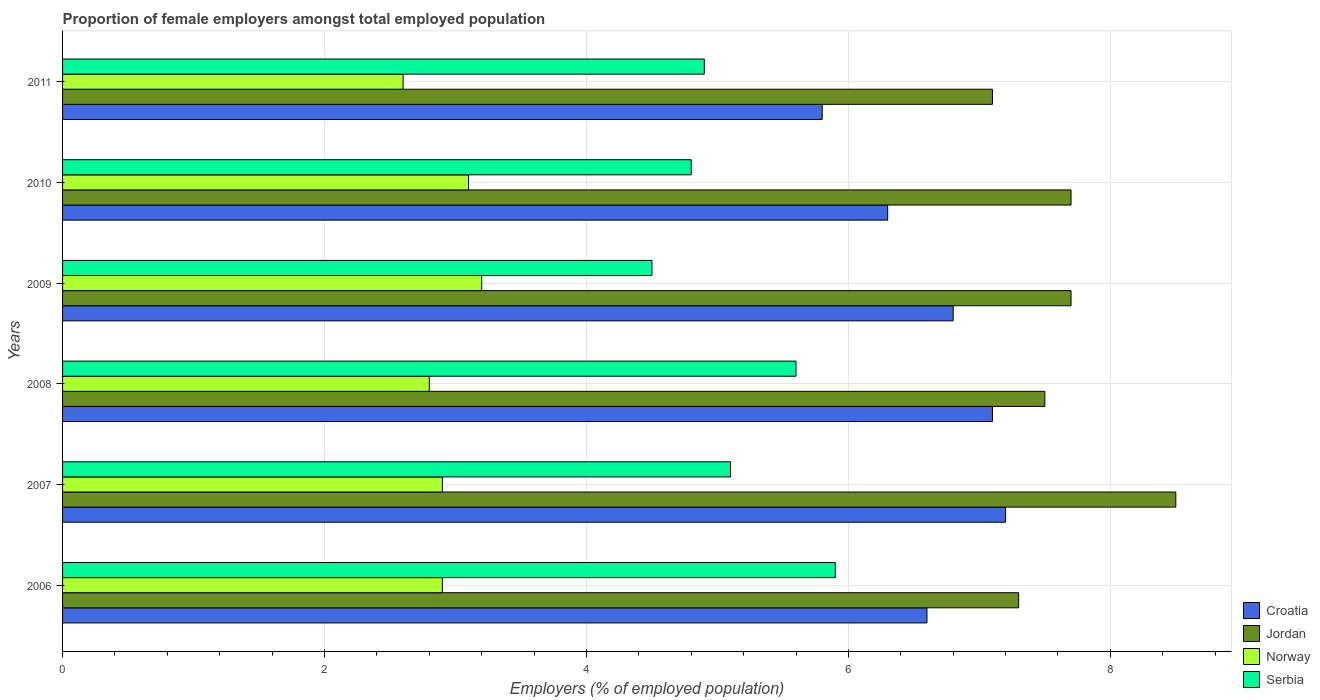How many different coloured bars are there?
Your answer should be compact. 4. Are the number of bars per tick equal to the number of legend labels?
Keep it short and to the point. Yes. How many bars are there on the 5th tick from the top?
Provide a succinct answer. 4. How many bars are there on the 4th tick from the bottom?
Your answer should be very brief. 4. In how many cases, is the number of bars for a given year not equal to the number of legend labels?
Provide a short and direct response. 0. What is the proportion of female employers in Croatia in 2007?
Ensure brevity in your answer.  7.2. Across all years, what is the minimum proportion of female employers in Croatia?
Offer a very short reply. 5.8. In which year was the proportion of female employers in Croatia minimum?
Ensure brevity in your answer.  2011. What is the total proportion of female employers in Jordan in the graph?
Your answer should be compact. 45.8. What is the difference between the proportion of female employers in Serbia in 2007 and that in 2010?
Provide a short and direct response. 0.3. What is the average proportion of female employers in Serbia per year?
Give a very brief answer. 5.13. In the year 2006, what is the difference between the proportion of female employers in Croatia and proportion of female employers in Norway?
Your response must be concise. 3.7. In how many years, is the proportion of female employers in Jordan greater than 8.4 %?
Ensure brevity in your answer.  1. What is the ratio of the proportion of female employers in Serbia in 2007 to that in 2010?
Your response must be concise. 1.06. Is the difference between the proportion of female employers in Croatia in 2008 and 2011 greater than the difference between the proportion of female employers in Norway in 2008 and 2011?
Keep it short and to the point. Yes. What is the difference between the highest and the second highest proportion of female employers in Serbia?
Keep it short and to the point. 0.3. What is the difference between the highest and the lowest proportion of female employers in Jordan?
Offer a very short reply. 1.4. In how many years, is the proportion of female employers in Jordan greater than the average proportion of female employers in Jordan taken over all years?
Give a very brief answer. 3. Is the sum of the proportion of female employers in Jordan in 2006 and 2010 greater than the maximum proportion of female employers in Croatia across all years?
Give a very brief answer. Yes. Is it the case that in every year, the sum of the proportion of female employers in Croatia and proportion of female employers in Norway is greater than the sum of proportion of female employers in Serbia and proportion of female employers in Jordan?
Provide a succinct answer. Yes. What does the 2nd bar from the top in 2008 represents?
Offer a very short reply. Norway. What does the 1st bar from the bottom in 2006 represents?
Your response must be concise. Croatia. Are all the bars in the graph horizontal?
Your answer should be very brief. Yes. What is the difference between two consecutive major ticks on the X-axis?
Keep it short and to the point. 2. Are the values on the major ticks of X-axis written in scientific E-notation?
Offer a terse response. No. Does the graph contain grids?
Make the answer very short. Yes. Where does the legend appear in the graph?
Provide a succinct answer. Bottom right. What is the title of the graph?
Offer a terse response. Proportion of female employers amongst total employed population. What is the label or title of the X-axis?
Your response must be concise. Employers (% of employed population). What is the Employers (% of employed population) of Croatia in 2006?
Provide a short and direct response. 6.6. What is the Employers (% of employed population) of Jordan in 2006?
Your response must be concise. 7.3. What is the Employers (% of employed population) in Norway in 2006?
Ensure brevity in your answer.  2.9. What is the Employers (% of employed population) of Serbia in 2006?
Offer a terse response. 5.9. What is the Employers (% of employed population) in Croatia in 2007?
Keep it short and to the point. 7.2. What is the Employers (% of employed population) of Jordan in 2007?
Keep it short and to the point. 8.5. What is the Employers (% of employed population) of Norway in 2007?
Make the answer very short. 2.9. What is the Employers (% of employed population) in Serbia in 2007?
Your answer should be compact. 5.1. What is the Employers (% of employed population) of Croatia in 2008?
Offer a terse response. 7.1. What is the Employers (% of employed population) in Norway in 2008?
Your answer should be compact. 2.8. What is the Employers (% of employed population) in Serbia in 2008?
Provide a short and direct response. 5.6. What is the Employers (% of employed population) in Croatia in 2009?
Your answer should be very brief. 6.8. What is the Employers (% of employed population) in Jordan in 2009?
Make the answer very short. 7.7. What is the Employers (% of employed population) in Norway in 2009?
Make the answer very short. 3.2. What is the Employers (% of employed population) in Croatia in 2010?
Offer a terse response. 6.3. What is the Employers (% of employed population) of Jordan in 2010?
Give a very brief answer. 7.7. What is the Employers (% of employed population) of Norway in 2010?
Offer a terse response. 3.1. What is the Employers (% of employed population) in Serbia in 2010?
Your answer should be very brief. 4.8. What is the Employers (% of employed population) in Croatia in 2011?
Make the answer very short. 5.8. What is the Employers (% of employed population) in Jordan in 2011?
Your response must be concise. 7.1. What is the Employers (% of employed population) in Norway in 2011?
Your response must be concise. 2.6. What is the Employers (% of employed population) of Serbia in 2011?
Your answer should be very brief. 4.9. Across all years, what is the maximum Employers (% of employed population) in Croatia?
Offer a terse response. 7.2. Across all years, what is the maximum Employers (% of employed population) in Jordan?
Make the answer very short. 8.5. Across all years, what is the maximum Employers (% of employed population) of Norway?
Ensure brevity in your answer.  3.2. Across all years, what is the maximum Employers (% of employed population) in Serbia?
Give a very brief answer. 5.9. Across all years, what is the minimum Employers (% of employed population) of Croatia?
Ensure brevity in your answer.  5.8. Across all years, what is the minimum Employers (% of employed population) of Jordan?
Make the answer very short. 7.1. Across all years, what is the minimum Employers (% of employed population) of Norway?
Offer a very short reply. 2.6. Across all years, what is the minimum Employers (% of employed population) of Serbia?
Ensure brevity in your answer.  4.5. What is the total Employers (% of employed population) of Croatia in the graph?
Offer a terse response. 39.8. What is the total Employers (% of employed population) in Jordan in the graph?
Offer a terse response. 45.8. What is the total Employers (% of employed population) in Norway in the graph?
Provide a short and direct response. 17.5. What is the total Employers (% of employed population) in Serbia in the graph?
Ensure brevity in your answer.  30.8. What is the difference between the Employers (% of employed population) of Croatia in 2006 and that in 2007?
Provide a succinct answer. -0.6. What is the difference between the Employers (% of employed population) of Jordan in 2006 and that in 2007?
Offer a very short reply. -1.2. What is the difference between the Employers (% of employed population) of Serbia in 2006 and that in 2007?
Your answer should be compact. 0.8. What is the difference between the Employers (% of employed population) of Croatia in 2006 and that in 2008?
Your response must be concise. -0.5. What is the difference between the Employers (% of employed population) in Serbia in 2006 and that in 2008?
Your answer should be very brief. 0.3. What is the difference between the Employers (% of employed population) in Croatia in 2006 and that in 2009?
Your answer should be compact. -0.2. What is the difference between the Employers (% of employed population) of Norway in 2006 and that in 2009?
Provide a short and direct response. -0.3. What is the difference between the Employers (% of employed population) in Serbia in 2006 and that in 2009?
Make the answer very short. 1.4. What is the difference between the Employers (% of employed population) in Croatia in 2006 and that in 2010?
Your answer should be compact. 0.3. What is the difference between the Employers (% of employed population) of Jordan in 2006 and that in 2010?
Provide a short and direct response. -0.4. What is the difference between the Employers (% of employed population) of Norway in 2006 and that in 2011?
Your answer should be compact. 0.3. What is the difference between the Employers (% of employed population) in Serbia in 2006 and that in 2011?
Offer a very short reply. 1. What is the difference between the Employers (% of employed population) of Norway in 2007 and that in 2008?
Give a very brief answer. 0.1. What is the difference between the Employers (% of employed population) of Croatia in 2007 and that in 2009?
Your response must be concise. 0.4. What is the difference between the Employers (% of employed population) in Croatia in 2007 and that in 2010?
Your response must be concise. 0.9. What is the difference between the Employers (% of employed population) of Jordan in 2007 and that in 2010?
Provide a short and direct response. 0.8. What is the difference between the Employers (% of employed population) of Croatia in 2007 and that in 2011?
Ensure brevity in your answer.  1.4. What is the difference between the Employers (% of employed population) of Jordan in 2007 and that in 2011?
Your answer should be very brief. 1.4. What is the difference between the Employers (% of employed population) in Serbia in 2007 and that in 2011?
Offer a terse response. 0.2. What is the difference between the Employers (% of employed population) of Croatia in 2008 and that in 2010?
Provide a short and direct response. 0.8. What is the difference between the Employers (% of employed population) in Jordan in 2008 and that in 2010?
Ensure brevity in your answer.  -0.2. What is the difference between the Employers (% of employed population) in Serbia in 2008 and that in 2011?
Keep it short and to the point. 0.7. What is the difference between the Employers (% of employed population) in Croatia in 2009 and that in 2010?
Provide a succinct answer. 0.5. What is the difference between the Employers (% of employed population) in Jordan in 2009 and that in 2010?
Your answer should be very brief. 0. What is the difference between the Employers (% of employed population) in Serbia in 2009 and that in 2010?
Give a very brief answer. -0.3. What is the difference between the Employers (% of employed population) in Jordan in 2009 and that in 2011?
Your response must be concise. 0.6. What is the difference between the Employers (% of employed population) in Serbia in 2009 and that in 2011?
Ensure brevity in your answer.  -0.4. What is the difference between the Employers (% of employed population) of Croatia in 2010 and that in 2011?
Make the answer very short. 0.5. What is the difference between the Employers (% of employed population) of Jordan in 2010 and that in 2011?
Your response must be concise. 0.6. What is the difference between the Employers (% of employed population) of Norway in 2010 and that in 2011?
Your answer should be very brief. 0.5. What is the difference between the Employers (% of employed population) of Serbia in 2010 and that in 2011?
Your response must be concise. -0.1. What is the difference between the Employers (% of employed population) of Croatia in 2006 and the Employers (% of employed population) of Jordan in 2007?
Ensure brevity in your answer.  -1.9. What is the difference between the Employers (% of employed population) of Croatia in 2006 and the Employers (% of employed population) of Norway in 2007?
Provide a succinct answer. 3.7. What is the difference between the Employers (% of employed population) of Jordan in 2006 and the Employers (% of employed population) of Serbia in 2007?
Make the answer very short. 2.2. What is the difference between the Employers (% of employed population) in Norway in 2006 and the Employers (% of employed population) in Serbia in 2007?
Your answer should be compact. -2.2. What is the difference between the Employers (% of employed population) in Croatia in 2006 and the Employers (% of employed population) in Jordan in 2008?
Offer a very short reply. -0.9. What is the difference between the Employers (% of employed population) of Croatia in 2006 and the Employers (% of employed population) of Norway in 2008?
Keep it short and to the point. 3.8. What is the difference between the Employers (% of employed population) of Jordan in 2006 and the Employers (% of employed population) of Norway in 2008?
Keep it short and to the point. 4.5. What is the difference between the Employers (% of employed population) of Jordan in 2006 and the Employers (% of employed population) of Serbia in 2008?
Ensure brevity in your answer.  1.7. What is the difference between the Employers (% of employed population) of Croatia in 2006 and the Employers (% of employed population) of Jordan in 2009?
Ensure brevity in your answer.  -1.1. What is the difference between the Employers (% of employed population) of Croatia in 2006 and the Employers (% of employed population) of Serbia in 2009?
Keep it short and to the point. 2.1. What is the difference between the Employers (% of employed population) in Jordan in 2006 and the Employers (% of employed population) in Norway in 2009?
Make the answer very short. 4.1. What is the difference between the Employers (% of employed population) of Norway in 2006 and the Employers (% of employed population) of Serbia in 2009?
Keep it short and to the point. -1.6. What is the difference between the Employers (% of employed population) of Croatia in 2006 and the Employers (% of employed population) of Jordan in 2010?
Provide a succinct answer. -1.1. What is the difference between the Employers (% of employed population) of Jordan in 2006 and the Employers (% of employed population) of Norway in 2010?
Give a very brief answer. 4.2. What is the difference between the Employers (% of employed population) in Jordan in 2006 and the Employers (% of employed population) in Serbia in 2010?
Offer a terse response. 2.5. What is the difference between the Employers (% of employed population) of Croatia in 2006 and the Employers (% of employed population) of Jordan in 2011?
Your response must be concise. -0.5. What is the difference between the Employers (% of employed population) in Jordan in 2006 and the Employers (% of employed population) in Norway in 2011?
Your answer should be compact. 4.7. What is the difference between the Employers (% of employed population) in Jordan in 2006 and the Employers (% of employed population) in Serbia in 2011?
Your response must be concise. 2.4. What is the difference between the Employers (% of employed population) of Croatia in 2007 and the Employers (% of employed population) of Jordan in 2008?
Provide a short and direct response. -0.3. What is the difference between the Employers (% of employed population) of Croatia in 2007 and the Employers (% of employed population) of Norway in 2008?
Your response must be concise. 4.4. What is the difference between the Employers (% of employed population) of Croatia in 2007 and the Employers (% of employed population) of Serbia in 2008?
Offer a terse response. 1.6. What is the difference between the Employers (% of employed population) in Jordan in 2007 and the Employers (% of employed population) in Norway in 2008?
Give a very brief answer. 5.7. What is the difference between the Employers (% of employed population) of Jordan in 2007 and the Employers (% of employed population) of Serbia in 2008?
Give a very brief answer. 2.9. What is the difference between the Employers (% of employed population) of Croatia in 2007 and the Employers (% of employed population) of Norway in 2009?
Provide a succinct answer. 4. What is the difference between the Employers (% of employed population) of Jordan in 2007 and the Employers (% of employed population) of Norway in 2009?
Make the answer very short. 5.3. What is the difference between the Employers (% of employed population) in Croatia in 2007 and the Employers (% of employed population) in Serbia in 2010?
Offer a terse response. 2.4. What is the difference between the Employers (% of employed population) of Norway in 2007 and the Employers (% of employed population) of Serbia in 2010?
Provide a succinct answer. -1.9. What is the difference between the Employers (% of employed population) in Croatia in 2007 and the Employers (% of employed population) in Serbia in 2011?
Ensure brevity in your answer.  2.3. What is the difference between the Employers (% of employed population) of Jordan in 2007 and the Employers (% of employed population) of Norway in 2011?
Provide a short and direct response. 5.9. What is the difference between the Employers (% of employed population) in Norway in 2007 and the Employers (% of employed population) in Serbia in 2011?
Make the answer very short. -2. What is the difference between the Employers (% of employed population) in Croatia in 2008 and the Employers (% of employed population) in Jordan in 2010?
Provide a succinct answer. -0.6. What is the difference between the Employers (% of employed population) of Croatia in 2008 and the Employers (% of employed population) of Serbia in 2010?
Provide a succinct answer. 2.3. What is the difference between the Employers (% of employed population) in Jordan in 2008 and the Employers (% of employed population) in Norway in 2010?
Make the answer very short. 4.4. What is the difference between the Employers (% of employed population) in Jordan in 2008 and the Employers (% of employed population) in Serbia in 2010?
Make the answer very short. 2.7. What is the difference between the Employers (% of employed population) of Norway in 2008 and the Employers (% of employed population) of Serbia in 2010?
Keep it short and to the point. -2. What is the difference between the Employers (% of employed population) in Croatia in 2008 and the Employers (% of employed population) in Jordan in 2011?
Keep it short and to the point. 0. What is the difference between the Employers (% of employed population) of Croatia in 2008 and the Employers (% of employed population) of Serbia in 2011?
Ensure brevity in your answer.  2.2. What is the difference between the Employers (% of employed population) in Jordan in 2008 and the Employers (% of employed population) in Norway in 2011?
Your response must be concise. 4.9. What is the difference between the Employers (% of employed population) in Jordan in 2008 and the Employers (% of employed population) in Serbia in 2011?
Provide a short and direct response. 2.6. What is the difference between the Employers (% of employed population) of Norway in 2008 and the Employers (% of employed population) of Serbia in 2011?
Your answer should be very brief. -2.1. What is the difference between the Employers (% of employed population) in Croatia in 2009 and the Employers (% of employed population) in Jordan in 2010?
Provide a short and direct response. -0.9. What is the difference between the Employers (% of employed population) of Croatia in 2009 and the Employers (% of employed population) of Serbia in 2010?
Provide a succinct answer. 2. What is the difference between the Employers (% of employed population) in Croatia in 2009 and the Employers (% of employed population) in Jordan in 2011?
Offer a very short reply. -0.3. What is the difference between the Employers (% of employed population) of Croatia in 2009 and the Employers (% of employed population) of Serbia in 2011?
Provide a succinct answer. 1.9. What is the difference between the Employers (% of employed population) of Jordan in 2009 and the Employers (% of employed population) of Serbia in 2011?
Provide a succinct answer. 2.8. What is the difference between the Employers (% of employed population) of Norway in 2009 and the Employers (% of employed population) of Serbia in 2011?
Keep it short and to the point. -1.7. What is the difference between the Employers (% of employed population) in Croatia in 2010 and the Employers (% of employed population) in Jordan in 2011?
Give a very brief answer. -0.8. What is the difference between the Employers (% of employed population) in Croatia in 2010 and the Employers (% of employed population) in Norway in 2011?
Ensure brevity in your answer.  3.7. What is the average Employers (% of employed population) of Croatia per year?
Offer a terse response. 6.63. What is the average Employers (% of employed population) in Jordan per year?
Offer a terse response. 7.63. What is the average Employers (% of employed population) of Norway per year?
Make the answer very short. 2.92. What is the average Employers (% of employed population) of Serbia per year?
Give a very brief answer. 5.13. In the year 2006, what is the difference between the Employers (% of employed population) in Croatia and Employers (% of employed population) in Jordan?
Provide a succinct answer. -0.7. In the year 2006, what is the difference between the Employers (% of employed population) in Croatia and Employers (% of employed population) in Norway?
Make the answer very short. 3.7. In the year 2006, what is the difference between the Employers (% of employed population) of Jordan and Employers (% of employed population) of Norway?
Offer a terse response. 4.4. In the year 2007, what is the difference between the Employers (% of employed population) of Croatia and Employers (% of employed population) of Jordan?
Your response must be concise. -1.3. In the year 2007, what is the difference between the Employers (% of employed population) of Jordan and Employers (% of employed population) of Norway?
Make the answer very short. 5.6. In the year 2007, what is the difference between the Employers (% of employed population) of Jordan and Employers (% of employed population) of Serbia?
Offer a terse response. 3.4. In the year 2008, what is the difference between the Employers (% of employed population) of Croatia and Employers (% of employed population) of Jordan?
Keep it short and to the point. -0.4. In the year 2008, what is the difference between the Employers (% of employed population) of Croatia and Employers (% of employed population) of Norway?
Provide a succinct answer. 4.3. In the year 2008, what is the difference between the Employers (% of employed population) in Croatia and Employers (% of employed population) in Serbia?
Provide a succinct answer. 1.5. In the year 2008, what is the difference between the Employers (% of employed population) in Jordan and Employers (% of employed population) in Serbia?
Provide a succinct answer. 1.9. In the year 2008, what is the difference between the Employers (% of employed population) in Norway and Employers (% of employed population) in Serbia?
Your answer should be compact. -2.8. In the year 2009, what is the difference between the Employers (% of employed population) of Croatia and Employers (% of employed population) of Jordan?
Make the answer very short. -0.9. In the year 2009, what is the difference between the Employers (% of employed population) of Jordan and Employers (% of employed population) of Norway?
Make the answer very short. 4.5. In the year 2009, what is the difference between the Employers (% of employed population) in Jordan and Employers (% of employed population) in Serbia?
Your response must be concise. 3.2. In the year 2009, what is the difference between the Employers (% of employed population) of Norway and Employers (% of employed population) of Serbia?
Your response must be concise. -1.3. In the year 2010, what is the difference between the Employers (% of employed population) in Croatia and Employers (% of employed population) in Norway?
Offer a very short reply. 3.2. In the year 2010, what is the difference between the Employers (% of employed population) in Jordan and Employers (% of employed population) in Norway?
Give a very brief answer. 4.6. In the year 2010, what is the difference between the Employers (% of employed population) in Norway and Employers (% of employed population) in Serbia?
Your answer should be compact. -1.7. In the year 2011, what is the difference between the Employers (% of employed population) of Croatia and Employers (% of employed population) of Jordan?
Provide a succinct answer. -1.3. In the year 2011, what is the difference between the Employers (% of employed population) in Croatia and Employers (% of employed population) in Norway?
Keep it short and to the point. 3.2. In the year 2011, what is the difference between the Employers (% of employed population) in Norway and Employers (% of employed population) in Serbia?
Ensure brevity in your answer.  -2.3. What is the ratio of the Employers (% of employed population) of Jordan in 2006 to that in 2007?
Your answer should be compact. 0.86. What is the ratio of the Employers (% of employed population) of Serbia in 2006 to that in 2007?
Your response must be concise. 1.16. What is the ratio of the Employers (% of employed population) of Croatia in 2006 to that in 2008?
Provide a succinct answer. 0.93. What is the ratio of the Employers (% of employed population) in Jordan in 2006 to that in 2008?
Provide a succinct answer. 0.97. What is the ratio of the Employers (% of employed population) of Norway in 2006 to that in 2008?
Offer a terse response. 1.04. What is the ratio of the Employers (% of employed population) in Serbia in 2006 to that in 2008?
Your answer should be compact. 1.05. What is the ratio of the Employers (% of employed population) of Croatia in 2006 to that in 2009?
Give a very brief answer. 0.97. What is the ratio of the Employers (% of employed population) in Jordan in 2006 to that in 2009?
Provide a succinct answer. 0.95. What is the ratio of the Employers (% of employed population) in Norway in 2006 to that in 2009?
Give a very brief answer. 0.91. What is the ratio of the Employers (% of employed population) in Serbia in 2006 to that in 2009?
Your answer should be compact. 1.31. What is the ratio of the Employers (% of employed population) of Croatia in 2006 to that in 2010?
Offer a very short reply. 1.05. What is the ratio of the Employers (% of employed population) of Jordan in 2006 to that in 2010?
Your answer should be very brief. 0.95. What is the ratio of the Employers (% of employed population) of Norway in 2006 to that in 2010?
Your answer should be compact. 0.94. What is the ratio of the Employers (% of employed population) of Serbia in 2006 to that in 2010?
Keep it short and to the point. 1.23. What is the ratio of the Employers (% of employed population) of Croatia in 2006 to that in 2011?
Give a very brief answer. 1.14. What is the ratio of the Employers (% of employed population) of Jordan in 2006 to that in 2011?
Provide a short and direct response. 1.03. What is the ratio of the Employers (% of employed population) in Norway in 2006 to that in 2011?
Make the answer very short. 1.12. What is the ratio of the Employers (% of employed population) in Serbia in 2006 to that in 2011?
Provide a succinct answer. 1.2. What is the ratio of the Employers (% of employed population) in Croatia in 2007 to that in 2008?
Your response must be concise. 1.01. What is the ratio of the Employers (% of employed population) in Jordan in 2007 to that in 2008?
Give a very brief answer. 1.13. What is the ratio of the Employers (% of employed population) in Norway in 2007 to that in 2008?
Keep it short and to the point. 1.04. What is the ratio of the Employers (% of employed population) in Serbia in 2007 to that in 2008?
Give a very brief answer. 0.91. What is the ratio of the Employers (% of employed population) of Croatia in 2007 to that in 2009?
Your answer should be compact. 1.06. What is the ratio of the Employers (% of employed population) of Jordan in 2007 to that in 2009?
Make the answer very short. 1.1. What is the ratio of the Employers (% of employed population) of Norway in 2007 to that in 2009?
Give a very brief answer. 0.91. What is the ratio of the Employers (% of employed population) of Serbia in 2007 to that in 2009?
Provide a succinct answer. 1.13. What is the ratio of the Employers (% of employed population) in Jordan in 2007 to that in 2010?
Keep it short and to the point. 1.1. What is the ratio of the Employers (% of employed population) in Norway in 2007 to that in 2010?
Your response must be concise. 0.94. What is the ratio of the Employers (% of employed population) of Serbia in 2007 to that in 2010?
Give a very brief answer. 1.06. What is the ratio of the Employers (% of employed population) of Croatia in 2007 to that in 2011?
Your answer should be compact. 1.24. What is the ratio of the Employers (% of employed population) of Jordan in 2007 to that in 2011?
Give a very brief answer. 1.2. What is the ratio of the Employers (% of employed population) in Norway in 2007 to that in 2011?
Give a very brief answer. 1.12. What is the ratio of the Employers (% of employed population) of Serbia in 2007 to that in 2011?
Ensure brevity in your answer.  1.04. What is the ratio of the Employers (% of employed population) of Croatia in 2008 to that in 2009?
Offer a very short reply. 1.04. What is the ratio of the Employers (% of employed population) of Jordan in 2008 to that in 2009?
Provide a succinct answer. 0.97. What is the ratio of the Employers (% of employed population) in Norway in 2008 to that in 2009?
Make the answer very short. 0.88. What is the ratio of the Employers (% of employed population) of Serbia in 2008 to that in 2009?
Provide a succinct answer. 1.24. What is the ratio of the Employers (% of employed population) in Croatia in 2008 to that in 2010?
Your response must be concise. 1.13. What is the ratio of the Employers (% of employed population) of Jordan in 2008 to that in 2010?
Offer a terse response. 0.97. What is the ratio of the Employers (% of employed population) of Norway in 2008 to that in 2010?
Give a very brief answer. 0.9. What is the ratio of the Employers (% of employed population) of Croatia in 2008 to that in 2011?
Keep it short and to the point. 1.22. What is the ratio of the Employers (% of employed population) of Jordan in 2008 to that in 2011?
Offer a terse response. 1.06. What is the ratio of the Employers (% of employed population) in Norway in 2008 to that in 2011?
Offer a terse response. 1.08. What is the ratio of the Employers (% of employed population) of Serbia in 2008 to that in 2011?
Your answer should be compact. 1.14. What is the ratio of the Employers (% of employed population) of Croatia in 2009 to that in 2010?
Provide a succinct answer. 1.08. What is the ratio of the Employers (% of employed population) in Norway in 2009 to that in 2010?
Your response must be concise. 1.03. What is the ratio of the Employers (% of employed population) in Croatia in 2009 to that in 2011?
Ensure brevity in your answer.  1.17. What is the ratio of the Employers (% of employed population) of Jordan in 2009 to that in 2011?
Your answer should be very brief. 1.08. What is the ratio of the Employers (% of employed population) in Norway in 2009 to that in 2011?
Keep it short and to the point. 1.23. What is the ratio of the Employers (% of employed population) of Serbia in 2009 to that in 2011?
Offer a terse response. 0.92. What is the ratio of the Employers (% of employed population) of Croatia in 2010 to that in 2011?
Your response must be concise. 1.09. What is the ratio of the Employers (% of employed population) of Jordan in 2010 to that in 2011?
Provide a short and direct response. 1.08. What is the ratio of the Employers (% of employed population) of Norway in 2010 to that in 2011?
Your answer should be compact. 1.19. What is the ratio of the Employers (% of employed population) of Serbia in 2010 to that in 2011?
Keep it short and to the point. 0.98. What is the difference between the highest and the second highest Employers (% of employed population) of Croatia?
Provide a short and direct response. 0.1. What is the difference between the highest and the second highest Employers (% of employed population) of Jordan?
Ensure brevity in your answer.  0.8. What is the difference between the highest and the second highest Employers (% of employed population) of Serbia?
Give a very brief answer. 0.3. What is the difference between the highest and the lowest Employers (% of employed population) in Jordan?
Provide a short and direct response. 1.4. What is the difference between the highest and the lowest Employers (% of employed population) in Norway?
Your response must be concise. 0.6. What is the difference between the highest and the lowest Employers (% of employed population) in Serbia?
Your response must be concise. 1.4. 